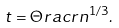Convert formula to latex. <formula><loc_0><loc_0><loc_500><loc_500>t = \Theta r a c { r } { n ^ { 1 / 3 } } .</formula> 